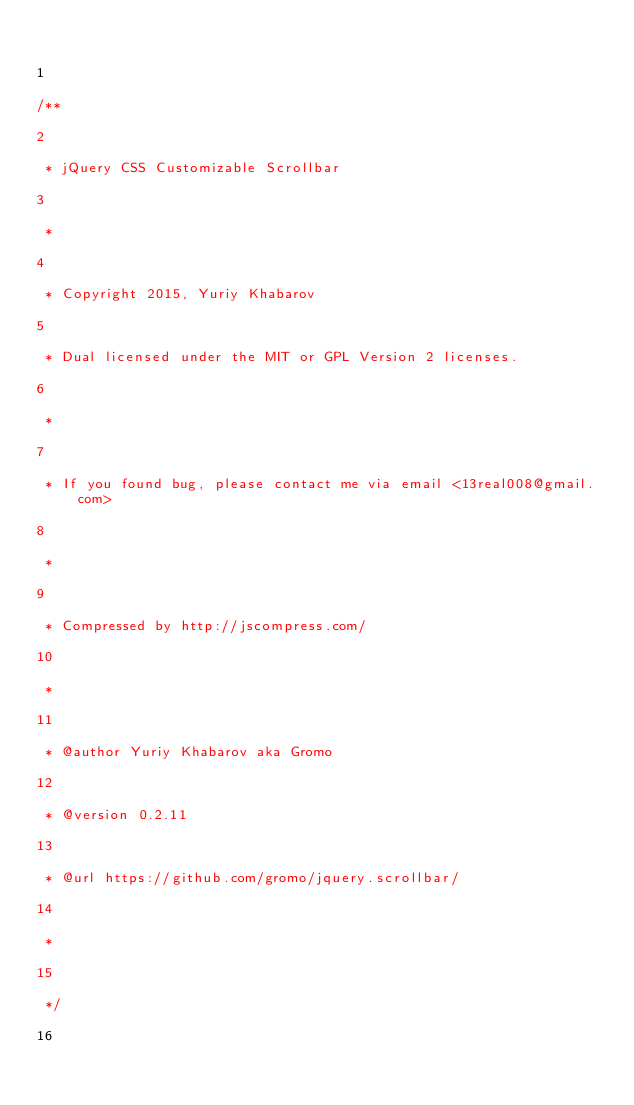<code> <loc_0><loc_0><loc_500><loc_500><_JavaScript_>

1

/**

2

 * jQuery CSS Customizable Scrollbar

3

 *

4

 * Copyright 2015, Yuriy Khabarov

5

 * Dual licensed under the MIT or GPL Version 2 licenses.

6

 *

7

 * If you found bug, please contact me via email <13real008@gmail.com>

8

 *

9

 * Compressed by http://jscompress.com/

10

 *

11

 * @author Yuriy Khabarov aka Gromo

12

 * @version 0.2.11

13

 * @url https://github.com/gromo/jquery.scrollbar/

14

 *

15

 */

16
</code> 